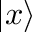Convert formula to latex. <formula><loc_0><loc_0><loc_500><loc_500>| x \rangle</formula> 